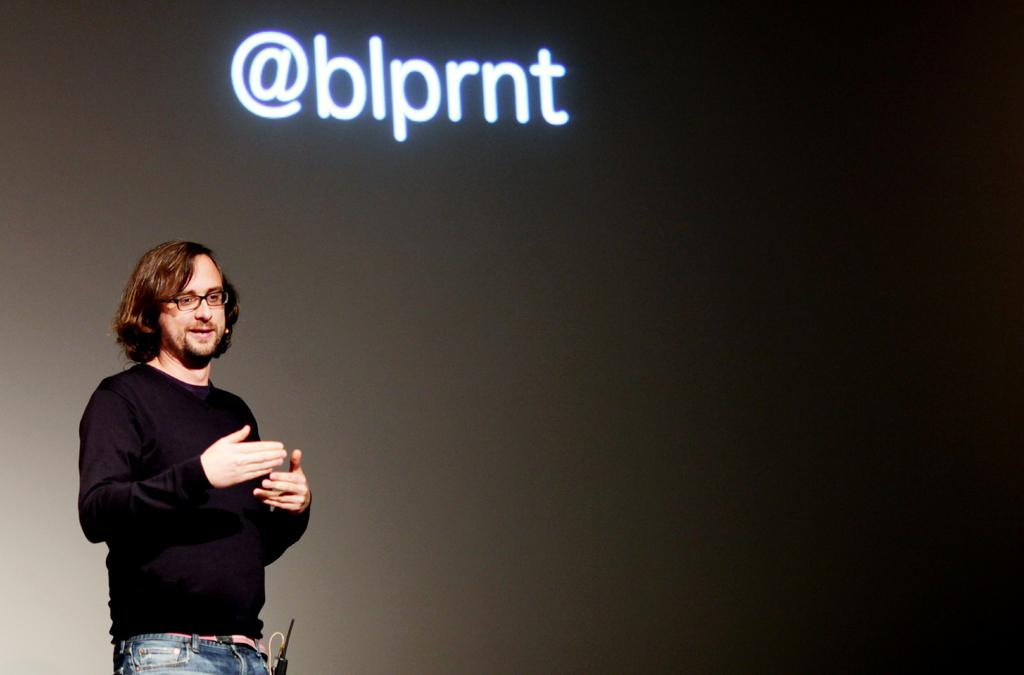Who is the main subject in the image? There is a man in the image. What is the man doing in the image? The man is giving a seminar. What is the man wearing in the image? The man is wearing a black shirt. What is located behind the man in the image? There is a screen behind the man. What is being displayed on the screen? Something is being displayed on the screen. How many rings are being worn by the mice in the image? There are no mice or rings present in the image. 